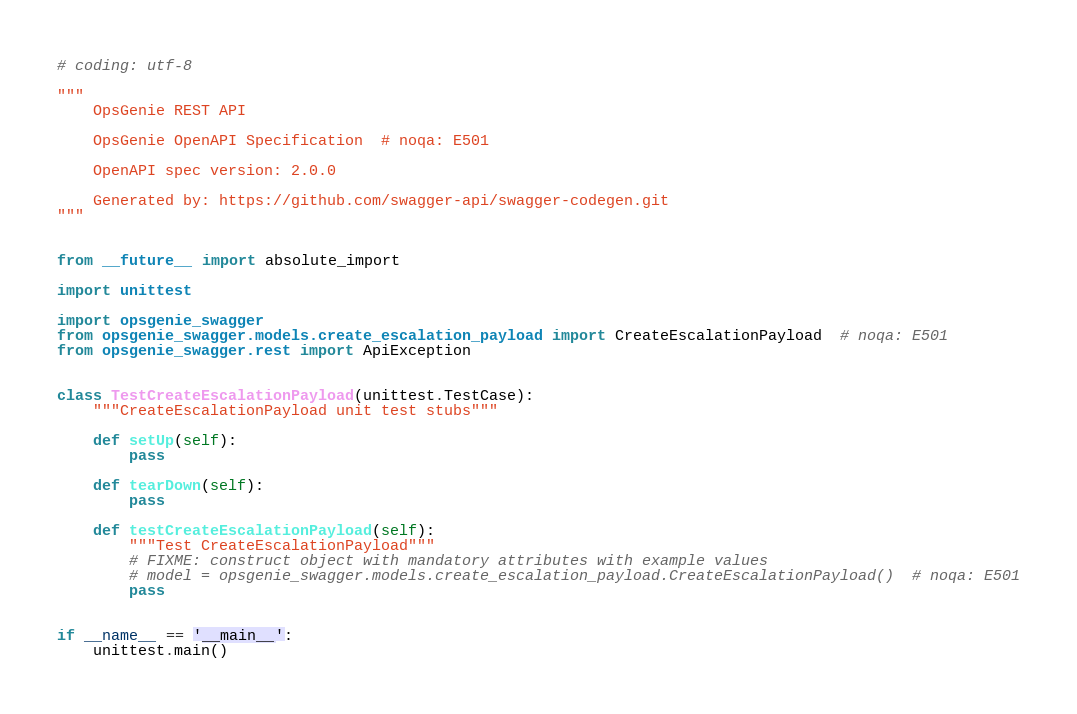Convert code to text. <code><loc_0><loc_0><loc_500><loc_500><_Python_># coding: utf-8

"""
    OpsGenie REST API

    OpsGenie OpenAPI Specification  # noqa: E501

    OpenAPI spec version: 2.0.0
    
    Generated by: https://github.com/swagger-api/swagger-codegen.git
"""


from __future__ import absolute_import

import unittest

import opsgenie_swagger
from opsgenie_swagger.models.create_escalation_payload import CreateEscalationPayload  # noqa: E501
from opsgenie_swagger.rest import ApiException


class TestCreateEscalationPayload(unittest.TestCase):
    """CreateEscalationPayload unit test stubs"""

    def setUp(self):
        pass

    def tearDown(self):
        pass

    def testCreateEscalationPayload(self):
        """Test CreateEscalationPayload"""
        # FIXME: construct object with mandatory attributes with example values
        # model = opsgenie_swagger.models.create_escalation_payload.CreateEscalationPayload()  # noqa: E501
        pass


if __name__ == '__main__':
    unittest.main()
</code> 